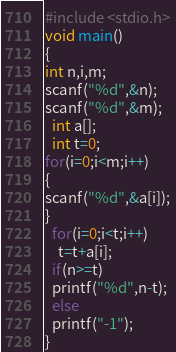Convert code to text. <code><loc_0><loc_0><loc_500><loc_500><_C_>#include <stdio.h>
void main()
{
int n,i,m;
scanf("%d",&n);
scanf("%d",&m);
  int a[];
  int t=0;
for(i=0;i<m;i++)
{
scanf("%d",&a[i]);
}
  for(i=0;i<t;i++)
    t=t+a[i];
  if(n>=t)
  printf("%d",n-t);
  else
  printf("-1");  
}</code> 